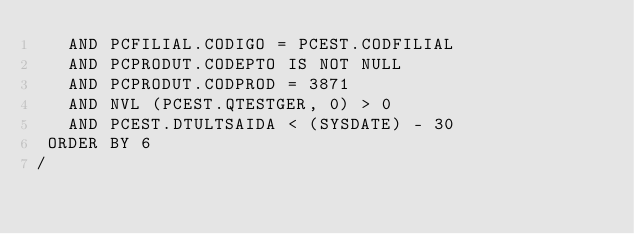Convert code to text. <code><loc_0><loc_0><loc_500><loc_500><_SQL_>   AND PCFILIAL.CODIGO = PCEST.CODFILIAL
   AND PCPRODUT.CODEPTO IS NOT NULL
   AND PCPRODUT.CODPROD = 3871
   AND NVL (PCEST.QTESTGER, 0) > 0
   AND PCEST.DTULTSAIDA < (SYSDATE) - 30
 ORDER BY 6
/</code> 